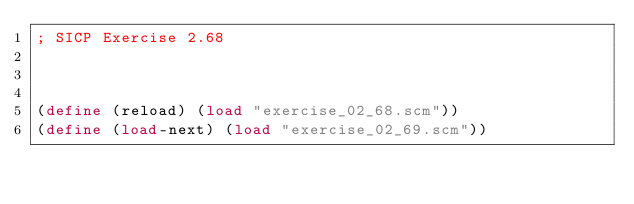Convert code to text. <code><loc_0><loc_0><loc_500><loc_500><_Scheme_>; SICP Exercise 2.68



(define (reload) (load "exercise_02_68.scm"))
(define (load-next) (load "exercise_02_69.scm"))

</code> 